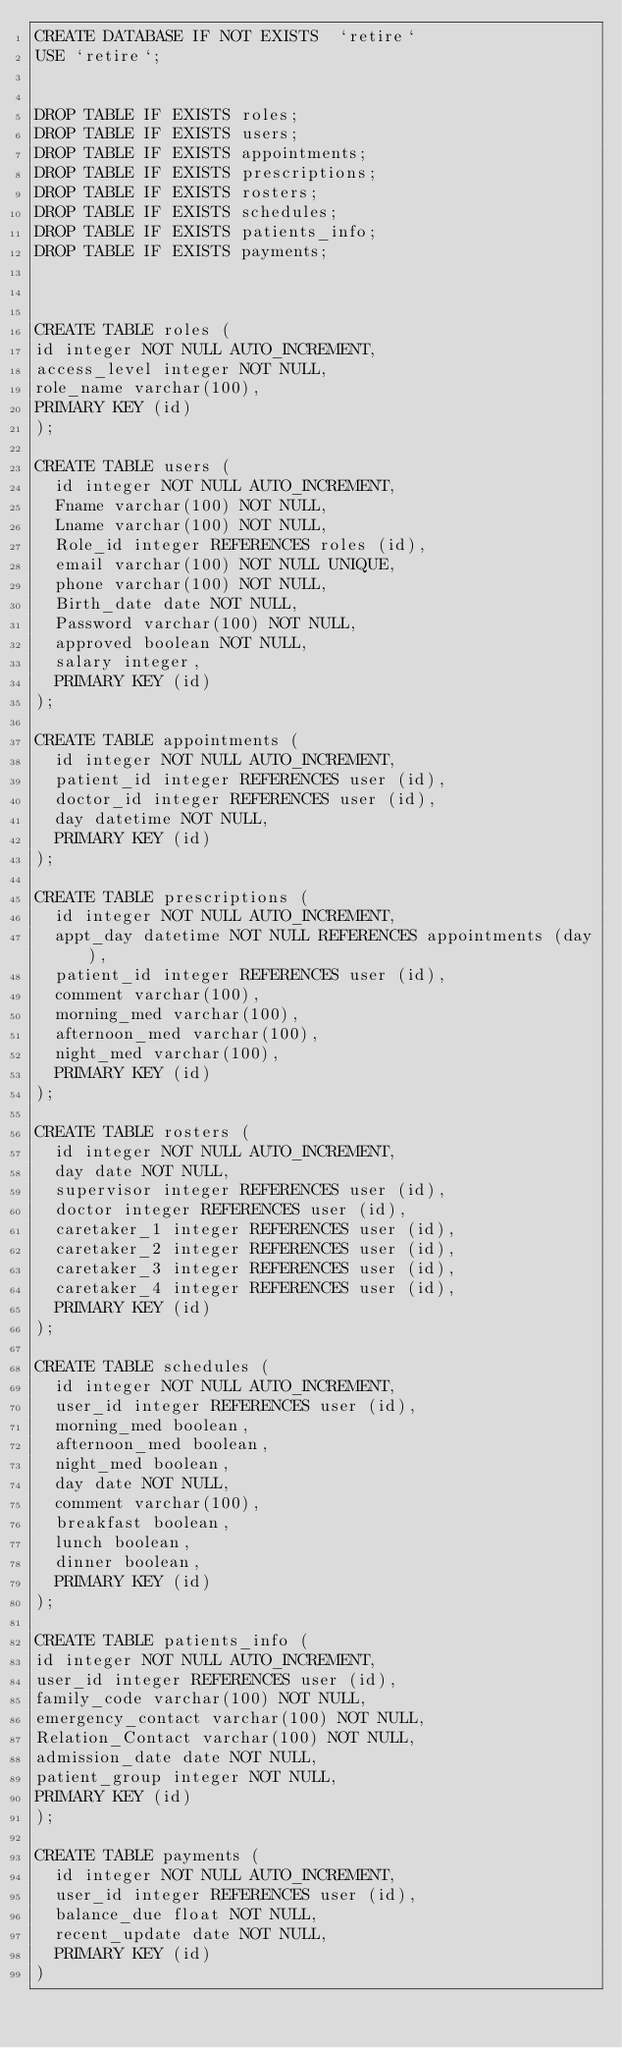Convert code to text. <code><loc_0><loc_0><loc_500><loc_500><_SQL_>CREATE DATABASE IF NOT EXISTS  `retire`
USE `retire`;


DROP TABLE IF EXISTS roles;
DROP TABLE IF EXISTS users;
DROP TABLE IF EXISTS appointments;
DROP TABLE IF EXISTS prescriptions;
DROP TABLE IF EXISTS rosters;
DROP TABLE IF EXISTS schedules;
DROP TABLE IF EXISTS patients_info;
DROP TABLE IF EXISTS payments;



CREATE TABLE roles (
id integer NOT NULL AUTO_INCREMENT,
access_level integer NOT NULL,
role_name varchar(100),
PRIMARY KEY (id)
);

CREATE TABLE users (
  id integer NOT NULL AUTO_INCREMENT,
  Fname varchar(100) NOT NULL,
  Lname varchar(100) NOT NULL,
  Role_id integer REFERENCES roles (id),
  email varchar(100) NOT NULL UNIQUE,
  phone varchar(100) NOT NULL,
  Birth_date date NOT NULL,
  Password varchar(100) NOT NULL,
  approved boolean NOT NULL,
  salary integer,
  PRIMARY KEY (id)
);

CREATE TABLE appointments (
  id integer NOT NULL AUTO_INCREMENT,
  patient_id integer REFERENCES user (id),
  doctor_id integer REFERENCES user (id),
  day datetime NOT NULL,
  PRIMARY KEY (id)
);

CREATE TABLE prescriptions (
  id integer NOT NULL AUTO_INCREMENT,
  appt_day datetime NOT NULL REFERENCES appointments (day),
  patient_id integer REFERENCES user (id),
  comment varchar(100),
  morning_med varchar(100),
  afternoon_med varchar(100),
  night_med varchar(100),
  PRIMARY KEY (id)
);

CREATE TABLE rosters (
  id integer NOT NULL AUTO_INCREMENT,
  day date NOT NULL,
  supervisor integer REFERENCES user (id),
  doctor integer REFERENCES user (id),
  caretaker_1 integer REFERENCES user (id),
  caretaker_2 integer REFERENCES user (id),
  caretaker_3 integer REFERENCES user (id),
  caretaker_4 integer REFERENCES user (id),
  PRIMARY KEY (id)
);

CREATE TABLE schedules (
  id integer NOT NULL AUTO_INCREMENT,
  user_id integer REFERENCES user (id),
  morning_med boolean,
  afternoon_med boolean,
  night_med boolean,
  day date NOT NULL,
  comment varchar(100),
  breakfast boolean,
  lunch boolean,
  dinner boolean,
  PRIMARY KEY (id)
);

CREATE TABLE patients_info (
id integer NOT NULL AUTO_INCREMENT,
user_id integer REFERENCES user (id),
family_code varchar(100) NOT NULL,
emergency_contact varchar(100) NOT NULL,
Relation_Contact varchar(100) NOT NULL,
admission_date date NOT NULL,
patient_group integer NOT NULL,
PRIMARY KEY (id)
);

CREATE TABLE payments (
  id integer NOT NULL AUTO_INCREMENT,
  user_id integer REFERENCES user (id),
  balance_due float NOT NULL,
  recent_update date NOT NULL,
  PRIMARY KEY (id)
)
</code> 